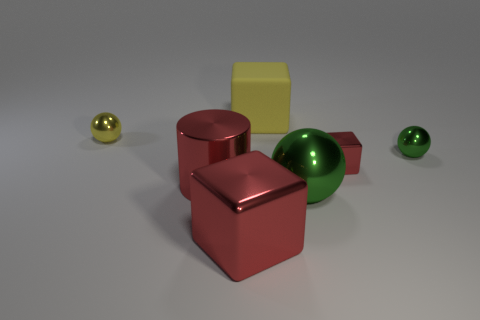Subtract all yellow balls. How many balls are left? 2 Add 2 cubes. How many objects exist? 9 Subtract all balls. How many objects are left? 4 Subtract all yellow spheres. How many spheres are left? 2 Subtract all purple spheres. How many red cubes are left? 2 Subtract 3 spheres. How many spheres are left? 0 Subtract all green blocks. Subtract all blue cylinders. How many blocks are left? 3 Subtract all green matte things. Subtract all big green shiny objects. How many objects are left? 6 Add 2 small green metallic balls. How many small green metallic balls are left? 3 Add 3 metallic things. How many metallic things exist? 9 